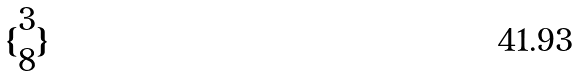Convert formula to latex. <formula><loc_0><loc_0><loc_500><loc_500>\{ \begin{matrix} 3 \\ 8 \end{matrix} \}</formula> 